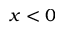Convert formula to latex. <formula><loc_0><loc_0><loc_500><loc_500>x < 0</formula> 